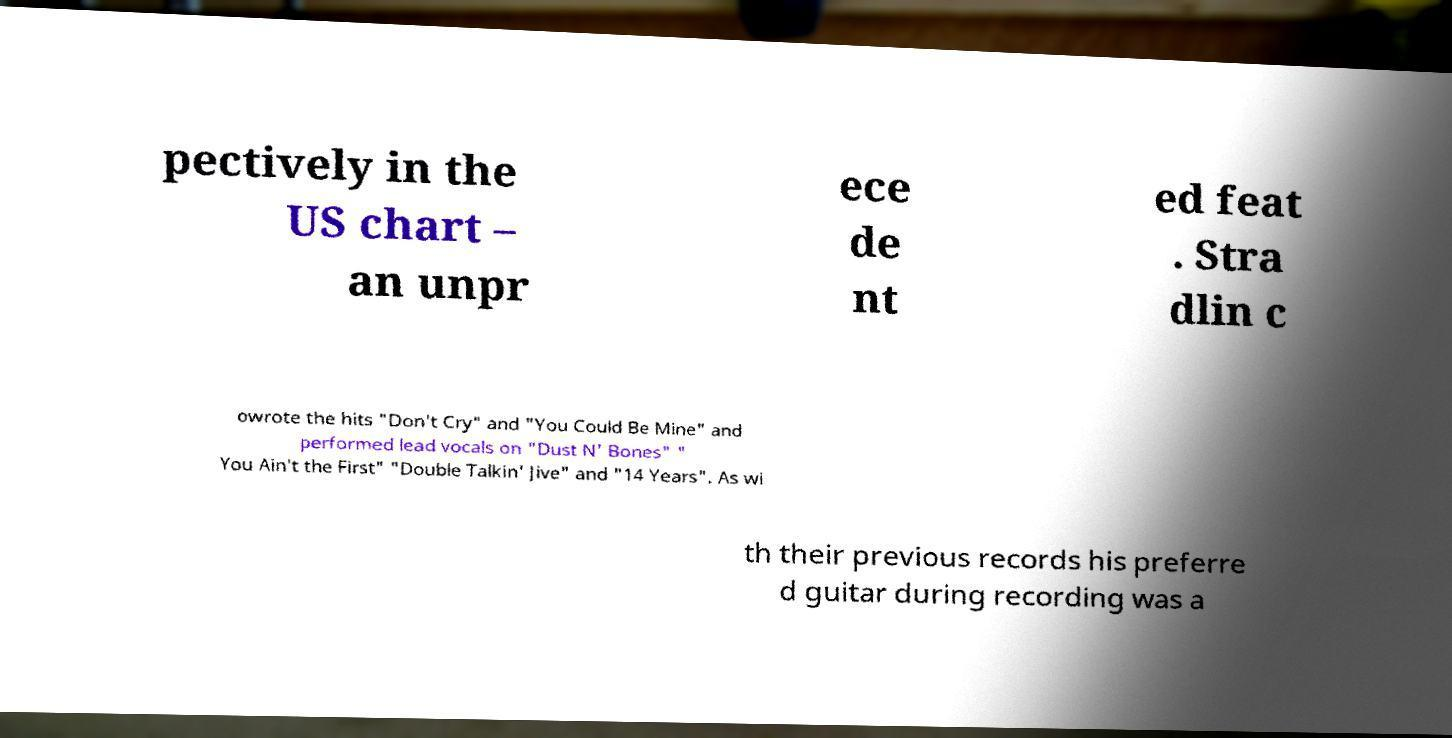Can you read and provide the text displayed in the image?This photo seems to have some interesting text. Can you extract and type it out for me? pectively in the US chart – an unpr ece de nt ed feat . Stra dlin c owrote the hits "Don't Cry" and "You Could Be Mine" and performed lead vocals on "Dust N' Bones" " You Ain't the First" "Double Talkin' Jive" and "14 Years". As wi th their previous records his preferre d guitar during recording was a 